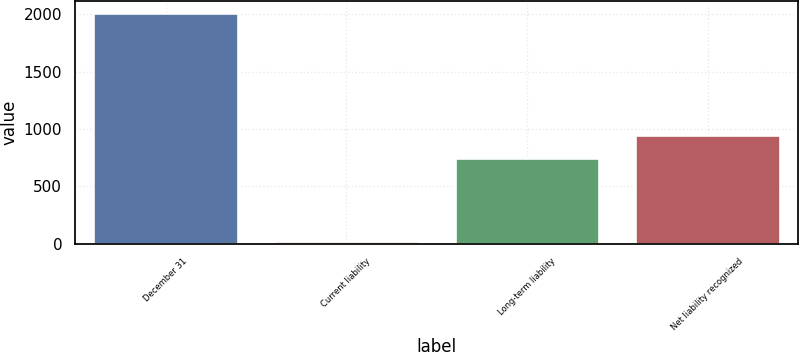Convert chart to OTSL. <chart><loc_0><loc_0><loc_500><loc_500><bar_chart><fcel>December 31<fcel>Current liability<fcel>Long-term liability<fcel>Net liability recognized<nl><fcel>2011<fcel>21<fcel>747<fcel>946<nl></chart> 